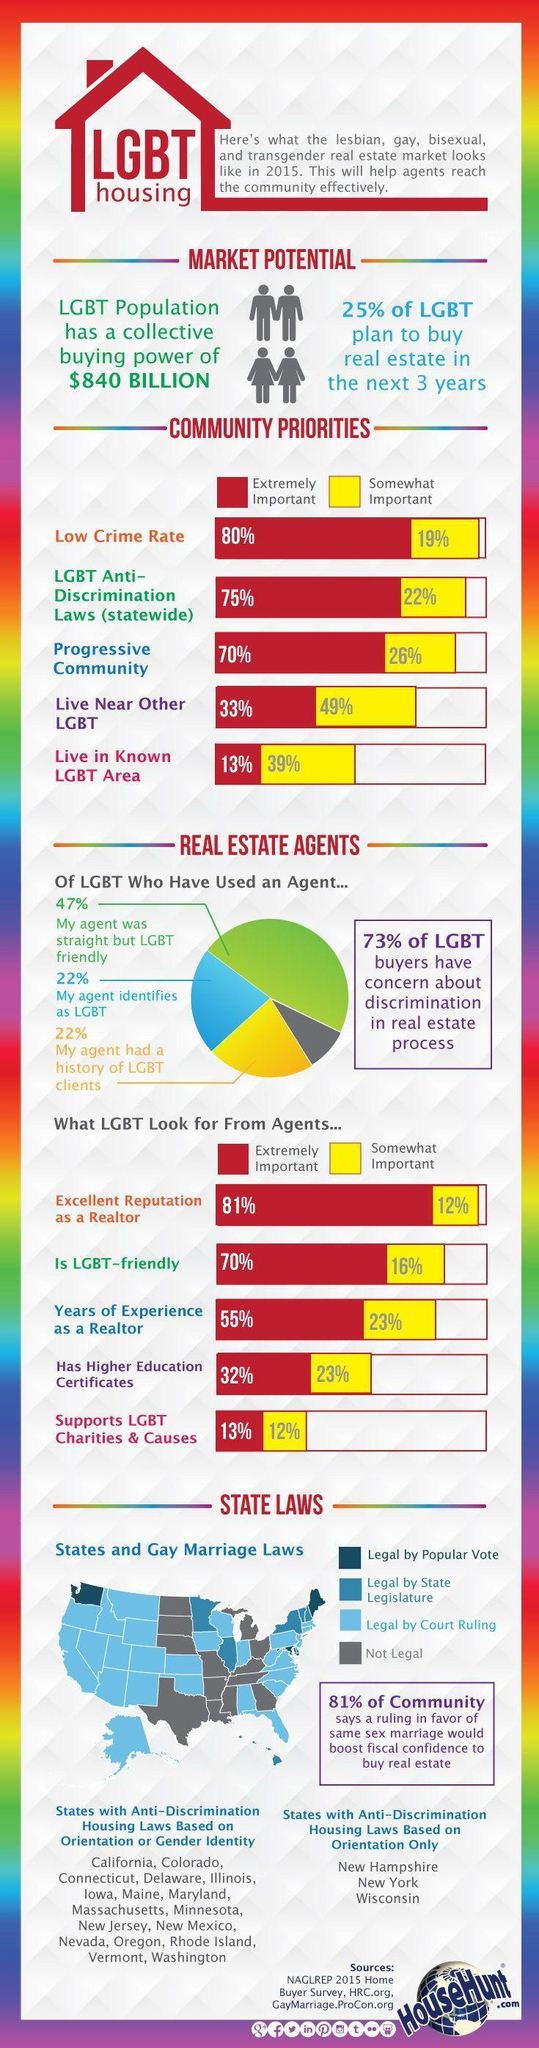how many states with anti-discrimination housing laws based on orientation only
Answer the question with a short phrase. 3 How many find living near other LGBT somewhat important community priority 49% how many of LGBT find it somewhat important for their agent to have higher education certificates 23% how many of LGBT who have used agent found that their agent was LGBT 22% 